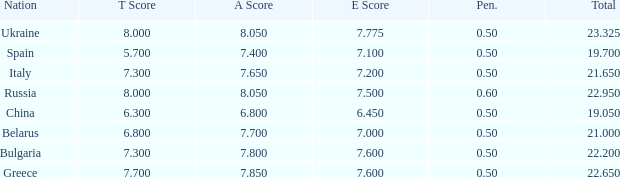What E score has the T score of 8 and a number smaller than 22.95? None. Can you give me this table as a dict? {'header': ['Nation', 'T Score', 'A Score', 'E Score', 'Pen.', 'Total'], 'rows': [['Ukraine', '8.000', '8.050', '7.775', '0.50', '23.325'], ['Spain', '5.700', '7.400', '7.100', '0.50', '19.700'], ['Italy', '7.300', '7.650', '7.200', '0.50', '21.650'], ['Russia', '8.000', '8.050', '7.500', '0.60', '22.950'], ['China', '6.300', '6.800', '6.450', '0.50', '19.050'], ['Belarus', '6.800', '7.700', '7.000', '0.50', '21.000'], ['Bulgaria', '7.300', '7.800', '7.600', '0.50', '22.200'], ['Greece', '7.700', '7.850', '7.600', '0.50', '22.650']]} 